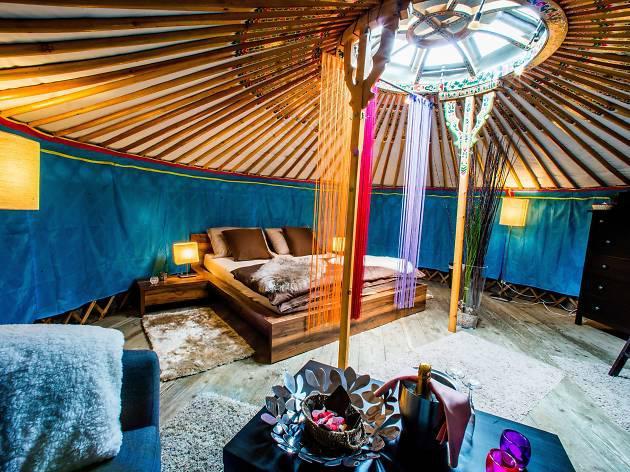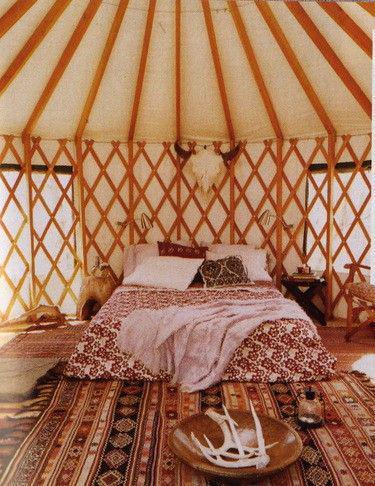The first image is the image on the left, the second image is the image on the right. For the images displayed, is the sentence "The lefthand image shows a yurt interior with an animal hide used in the bedroom decor." factually correct? Answer yes or no. Yes. The first image is the image on the left, the second image is the image on the right. Evaluate the accuracy of this statement regarding the images: "In one image, an office area with an oak office chair on wheels and laptop computer is adjacent to the foot of a bed with an oriental rug on the floor.". Is it true? Answer yes or no. No. 